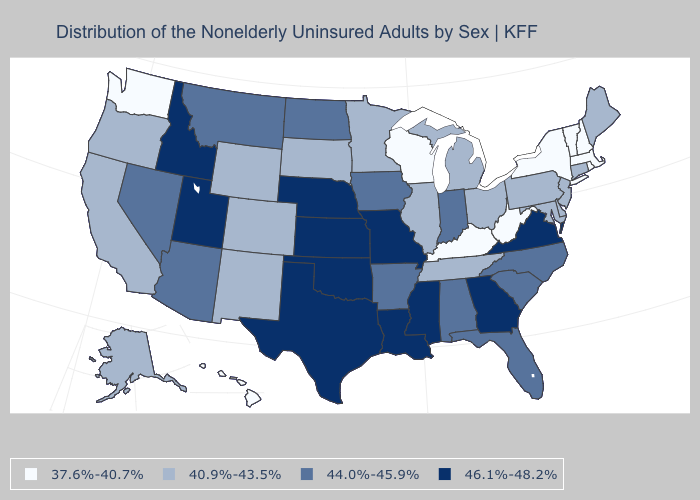Name the states that have a value in the range 40.9%-43.5%?
Be succinct. Alaska, California, Colorado, Connecticut, Delaware, Illinois, Maine, Maryland, Michigan, Minnesota, New Jersey, New Mexico, Ohio, Oregon, Pennsylvania, South Dakota, Tennessee, Wyoming. Which states have the highest value in the USA?
Quick response, please. Georgia, Idaho, Kansas, Louisiana, Mississippi, Missouri, Nebraska, Oklahoma, Texas, Utah, Virginia. Name the states that have a value in the range 37.6%-40.7%?
Keep it brief. Hawaii, Kentucky, Massachusetts, New Hampshire, New York, Rhode Island, Vermont, Washington, West Virginia, Wisconsin. How many symbols are there in the legend?
Write a very short answer. 4. Does Connecticut have a lower value than Utah?
Short answer required. Yes. Among the states that border Washington , which have the lowest value?
Keep it brief. Oregon. What is the value of Alaska?
Be succinct. 40.9%-43.5%. Does the first symbol in the legend represent the smallest category?
Quick response, please. Yes. What is the value of New Jersey?
Give a very brief answer. 40.9%-43.5%. What is the lowest value in the USA?
Keep it brief. 37.6%-40.7%. Does Montana have the highest value in the West?
Short answer required. No. How many symbols are there in the legend?
Write a very short answer. 4. What is the value of Louisiana?
Keep it brief. 46.1%-48.2%. Which states have the lowest value in the USA?
Answer briefly. Hawaii, Kentucky, Massachusetts, New Hampshire, New York, Rhode Island, Vermont, Washington, West Virginia, Wisconsin. Name the states that have a value in the range 46.1%-48.2%?
Answer briefly. Georgia, Idaho, Kansas, Louisiana, Mississippi, Missouri, Nebraska, Oklahoma, Texas, Utah, Virginia. 